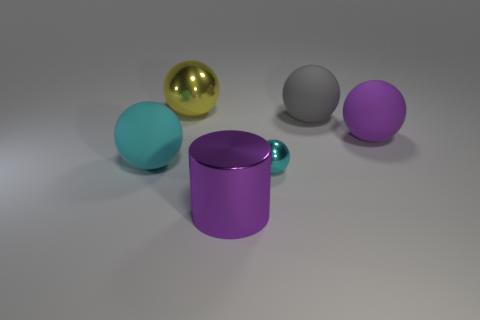Do the large gray object and the yellow object have the same shape?
Your answer should be compact. Yes. What number of yellow objects are the same shape as the large gray matte thing?
Offer a very short reply. 1. How many tiny green metallic blocks are there?
Provide a short and direct response. 0. What is the color of the metallic sphere behind the gray rubber sphere?
Give a very brief answer. Yellow. There is a metallic object that is behind the big matte object to the left of the tiny ball; what is its color?
Your answer should be very brief. Yellow. The cylinder that is the same size as the cyan matte object is what color?
Your answer should be compact. Purple. What number of metal balls are both in front of the large purple sphere and on the left side of the small metallic thing?
Offer a terse response. 0. There is a large rubber thing that is the same color as the tiny metal object; what shape is it?
Make the answer very short. Sphere. What material is the ball that is behind the purple rubber ball and to the left of the large gray matte ball?
Your answer should be compact. Metal. Are there fewer rubber things to the left of the tiny metal sphere than gray matte things to the left of the big cyan rubber sphere?
Keep it short and to the point. No. 